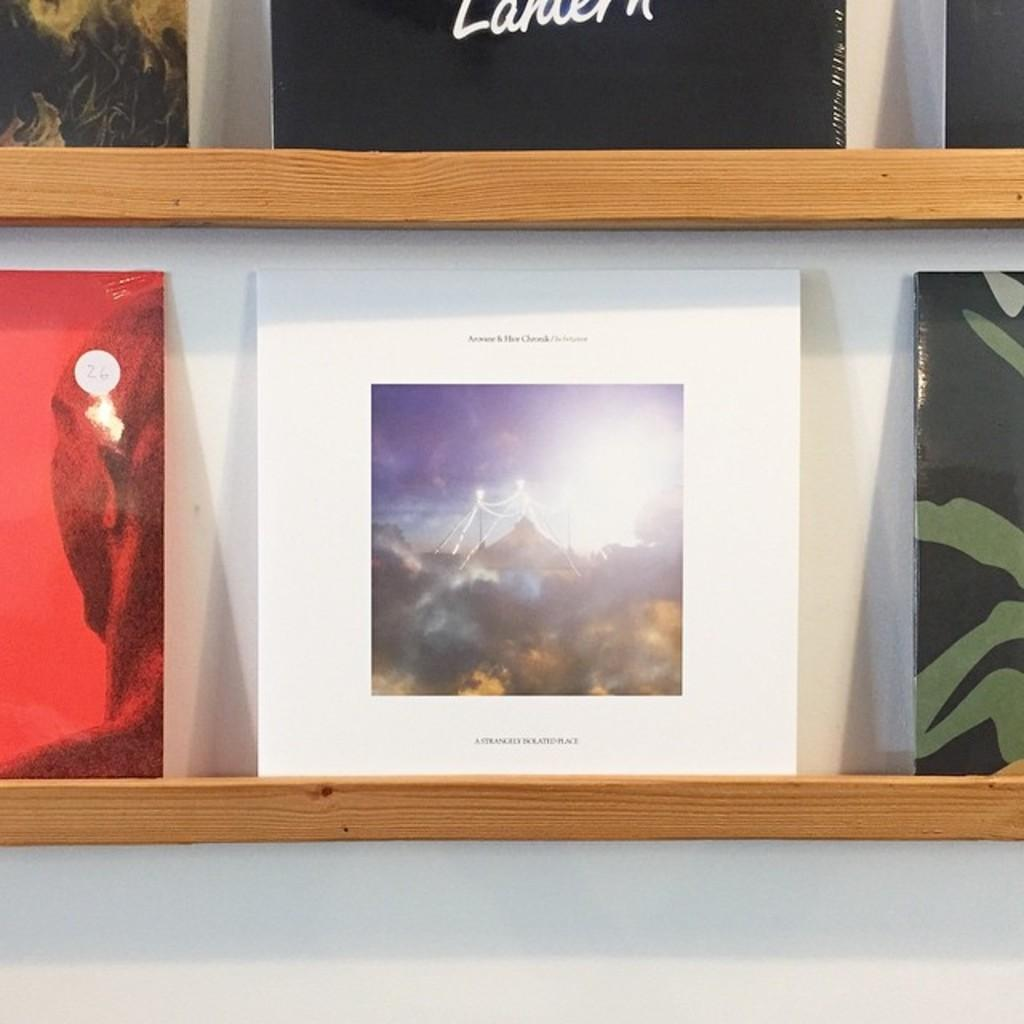<image>
Summarize the visual content of the image. some records on a shelf, one red with a white sticker that reads 26. 